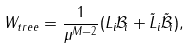Convert formula to latex. <formula><loc_0><loc_0><loc_500><loc_500>W _ { t r e e } = \frac { 1 } { \mu ^ { M - 2 } } ( L _ { i } \mathcal { B } _ { i } + \tilde { L } _ { i } \tilde { \mathcal { B } } _ { i } ) ,</formula> 